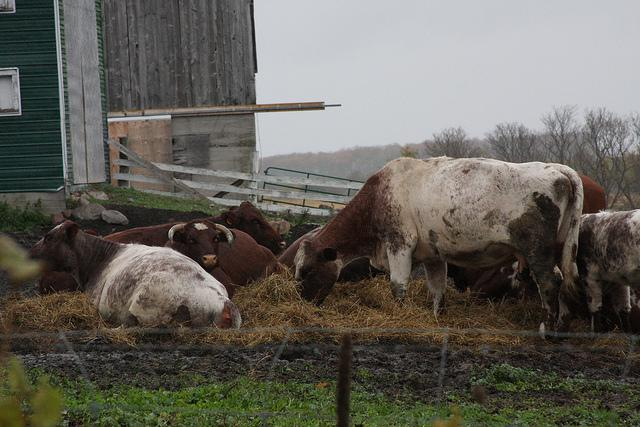The cows main food source for nutrition is brought out in what shape? bales 